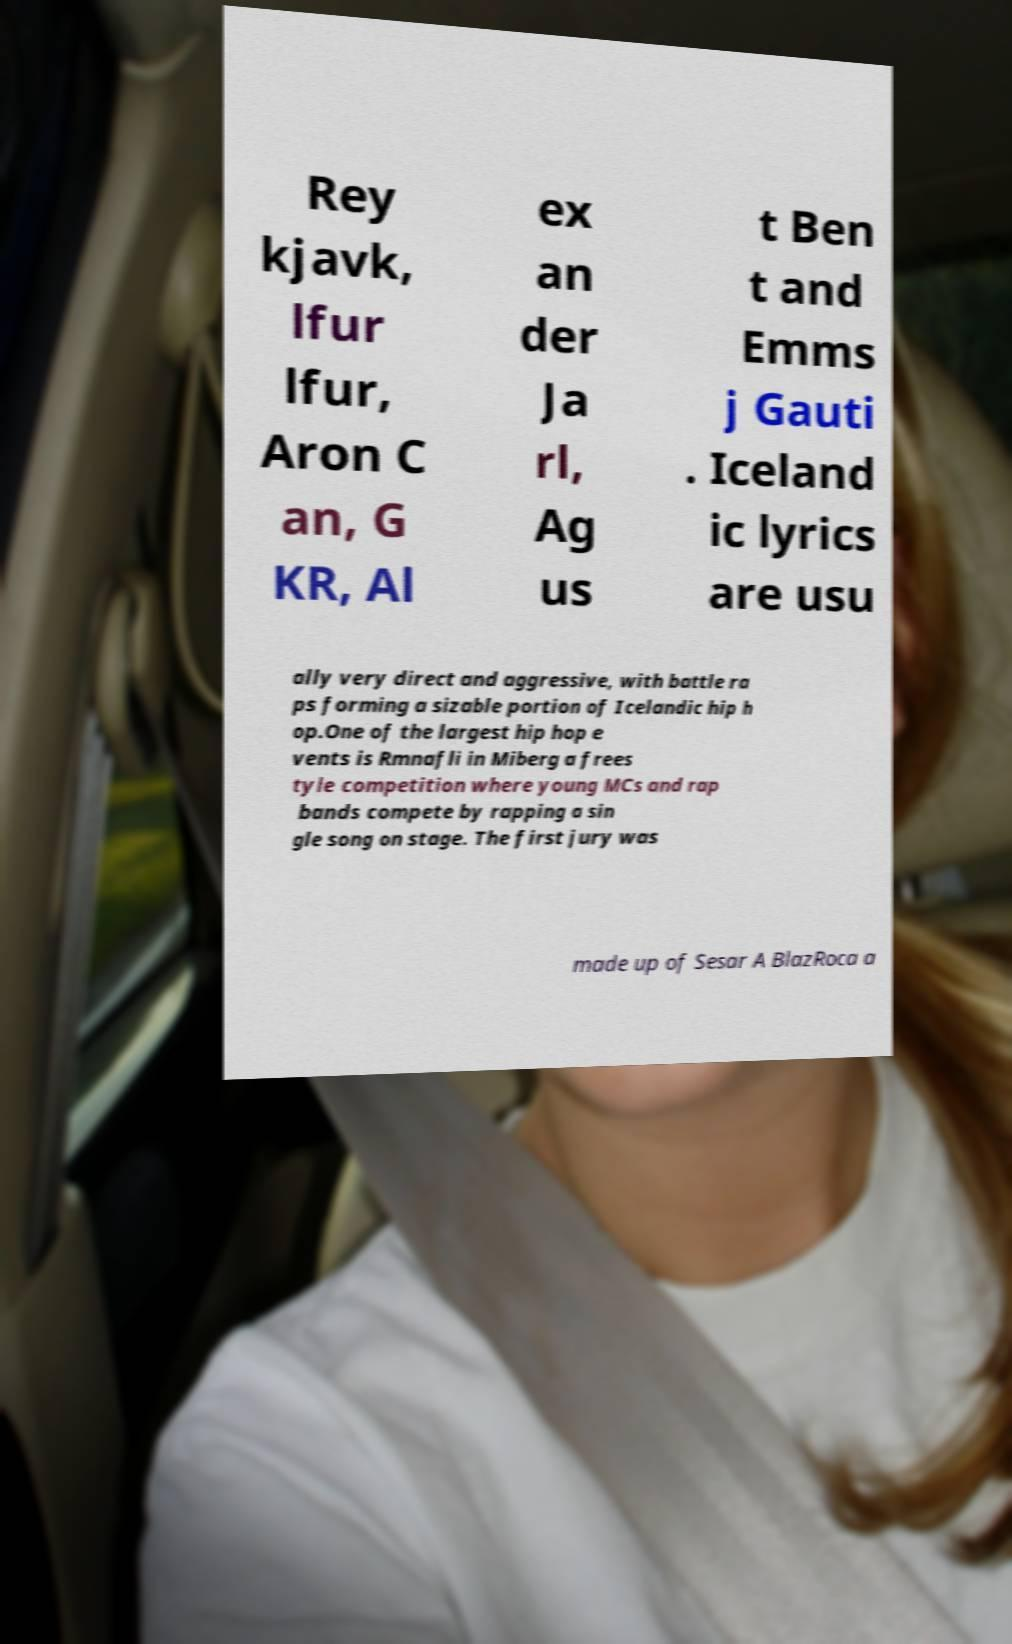Can you read and provide the text displayed in the image?This photo seems to have some interesting text. Can you extract and type it out for me? Rey kjavk, lfur lfur, Aron C an, G KR, Al ex an der Ja rl, Ag us t Ben t and Emms j Gauti . Iceland ic lyrics are usu ally very direct and aggressive, with battle ra ps forming a sizable portion of Icelandic hip h op.One of the largest hip hop e vents is Rmnafli in Miberg a frees tyle competition where young MCs and rap bands compete by rapping a sin gle song on stage. The first jury was made up of Sesar A BlazRoca a 